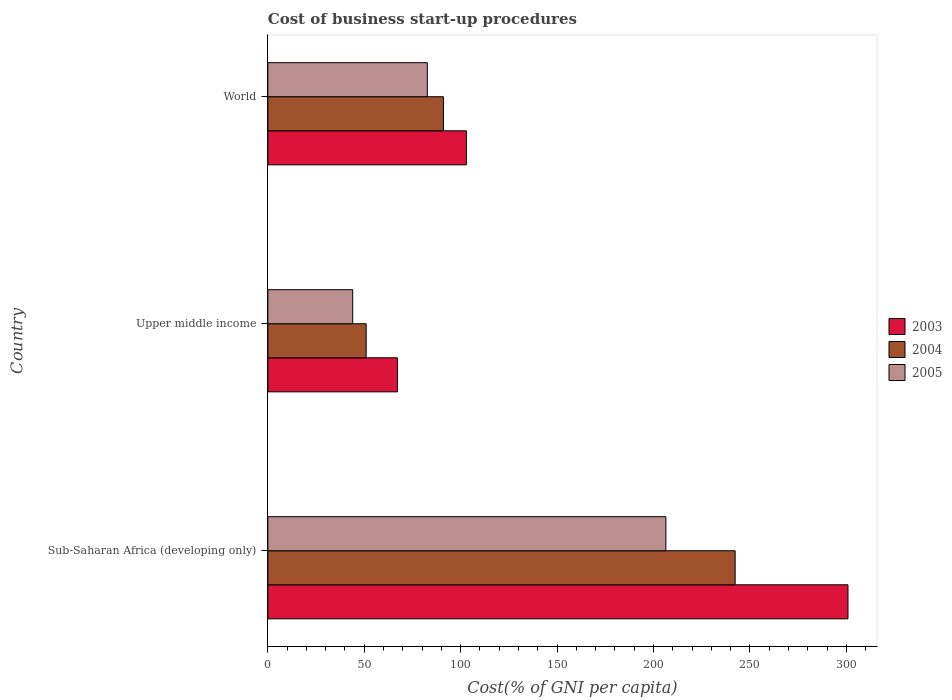How many different coloured bars are there?
Offer a very short reply. 3. How many groups of bars are there?
Give a very brief answer. 3. Are the number of bars per tick equal to the number of legend labels?
Offer a very short reply. Yes. What is the label of the 3rd group of bars from the top?
Your answer should be compact. Sub-Saharan Africa (developing only). In how many cases, is the number of bars for a given country not equal to the number of legend labels?
Your answer should be compact. 0. What is the cost of business start-up procedures in 2005 in Sub-Saharan Africa (developing only)?
Keep it short and to the point. 206.42. Across all countries, what is the maximum cost of business start-up procedures in 2005?
Make the answer very short. 206.42. Across all countries, what is the minimum cost of business start-up procedures in 2005?
Your response must be concise. 44.01. In which country was the cost of business start-up procedures in 2004 maximum?
Give a very brief answer. Sub-Saharan Africa (developing only). In which country was the cost of business start-up procedures in 2004 minimum?
Make the answer very short. Upper middle income. What is the total cost of business start-up procedures in 2003 in the graph?
Your answer should be compact. 471.05. What is the difference between the cost of business start-up procedures in 2005 in Sub-Saharan Africa (developing only) and that in Upper middle income?
Keep it short and to the point. 162.41. What is the difference between the cost of business start-up procedures in 2005 in Upper middle income and the cost of business start-up procedures in 2003 in Sub-Saharan Africa (developing only)?
Keep it short and to the point. -256.86. What is the average cost of business start-up procedures in 2003 per country?
Offer a terse response. 157.02. What is the difference between the cost of business start-up procedures in 2004 and cost of business start-up procedures in 2005 in World?
Your response must be concise. 8.36. In how many countries, is the cost of business start-up procedures in 2003 greater than 240 %?
Make the answer very short. 1. What is the ratio of the cost of business start-up procedures in 2005 in Sub-Saharan Africa (developing only) to that in World?
Give a very brief answer. 2.5. Is the cost of business start-up procedures in 2003 in Upper middle income less than that in World?
Provide a succinct answer. Yes. Is the difference between the cost of business start-up procedures in 2004 in Upper middle income and World greater than the difference between the cost of business start-up procedures in 2005 in Upper middle income and World?
Give a very brief answer. No. What is the difference between the highest and the second highest cost of business start-up procedures in 2004?
Your answer should be compact. 151.29. What is the difference between the highest and the lowest cost of business start-up procedures in 2005?
Your answer should be very brief. 162.41. In how many countries, is the cost of business start-up procedures in 2004 greater than the average cost of business start-up procedures in 2004 taken over all countries?
Your answer should be very brief. 1. What does the 1st bar from the bottom in Sub-Saharan Africa (developing only) represents?
Keep it short and to the point. 2003. Are all the bars in the graph horizontal?
Ensure brevity in your answer.  Yes. How many countries are there in the graph?
Your answer should be compact. 3. What is the difference between two consecutive major ticks on the X-axis?
Make the answer very short. 50. Where does the legend appear in the graph?
Your response must be concise. Center right. How many legend labels are there?
Your answer should be very brief. 3. How are the legend labels stacked?
Offer a terse response. Vertical. What is the title of the graph?
Keep it short and to the point. Cost of business start-up procedures. Does "1993" appear as one of the legend labels in the graph?
Offer a very short reply. No. What is the label or title of the X-axis?
Provide a succinct answer. Cost(% of GNI per capita). What is the Cost(% of GNI per capita) of 2003 in Sub-Saharan Africa (developing only)?
Your answer should be compact. 300.87. What is the Cost(% of GNI per capita) of 2004 in Sub-Saharan Africa (developing only)?
Offer a terse response. 242.35. What is the Cost(% of GNI per capita) of 2005 in Sub-Saharan Africa (developing only)?
Ensure brevity in your answer.  206.42. What is the Cost(% of GNI per capita) of 2003 in Upper middle income?
Offer a very short reply. 67.19. What is the Cost(% of GNI per capita) in 2004 in Upper middle income?
Ensure brevity in your answer.  51. What is the Cost(% of GNI per capita) of 2005 in Upper middle income?
Provide a succinct answer. 44.01. What is the Cost(% of GNI per capita) in 2003 in World?
Offer a very short reply. 103. What is the Cost(% of GNI per capita) in 2004 in World?
Provide a short and direct response. 91.06. What is the Cost(% of GNI per capita) in 2005 in World?
Offer a very short reply. 82.7. Across all countries, what is the maximum Cost(% of GNI per capita) in 2003?
Your answer should be very brief. 300.87. Across all countries, what is the maximum Cost(% of GNI per capita) in 2004?
Give a very brief answer. 242.35. Across all countries, what is the maximum Cost(% of GNI per capita) in 2005?
Offer a very short reply. 206.42. Across all countries, what is the minimum Cost(% of GNI per capita) of 2003?
Make the answer very short. 67.19. Across all countries, what is the minimum Cost(% of GNI per capita) of 2004?
Ensure brevity in your answer.  51. Across all countries, what is the minimum Cost(% of GNI per capita) in 2005?
Provide a succinct answer. 44.01. What is the total Cost(% of GNI per capita) in 2003 in the graph?
Make the answer very short. 471.05. What is the total Cost(% of GNI per capita) in 2004 in the graph?
Your response must be concise. 384.41. What is the total Cost(% of GNI per capita) in 2005 in the graph?
Ensure brevity in your answer.  333.13. What is the difference between the Cost(% of GNI per capita) of 2003 in Sub-Saharan Africa (developing only) and that in Upper middle income?
Your answer should be very brief. 233.68. What is the difference between the Cost(% of GNI per capita) in 2004 in Sub-Saharan Africa (developing only) and that in Upper middle income?
Make the answer very short. 191.35. What is the difference between the Cost(% of GNI per capita) in 2005 in Sub-Saharan Africa (developing only) and that in Upper middle income?
Keep it short and to the point. 162.41. What is the difference between the Cost(% of GNI per capita) of 2003 in Sub-Saharan Africa (developing only) and that in World?
Keep it short and to the point. 197.87. What is the difference between the Cost(% of GNI per capita) of 2004 in Sub-Saharan Africa (developing only) and that in World?
Offer a very short reply. 151.29. What is the difference between the Cost(% of GNI per capita) in 2005 in Sub-Saharan Africa (developing only) and that in World?
Your answer should be compact. 123.72. What is the difference between the Cost(% of GNI per capita) in 2003 in Upper middle income and that in World?
Make the answer very short. -35.81. What is the difference between the Cost(% of GNI per capita) in 2004 in Upper middle income and that in World?
Your response must be concise. -40.06. What is the difference between the Cost(% of GNI per capita) in 2005 in Upper middle income and that in World?
Your response must be concise. -38.69. What is the difference between the Cost(% of GNI per capita) of 2003 in Sub-Saharan Africa (developing only) and the Cost(% of GNI per capita) of 2004 in Upper middle income?
Offer a terse response. 249.87. What is the difference between the Cost(% of GNI per capita) of 2003 in Sub-Saharan Africa (developing only) and the Cost(% of GNI per capita) of 2005 in Upper middle income?
Keep it short and to the point. 256.86. What is the difference between the Cost(% of GNI per capita) in 2004 in Sub-Saharan Africa (developing only) and the Cost(% of GNI per capita) in 2005 in Upper middle income?
Give a very brief answer. 198.34. What is the difference between the Cost(% of GNI per capita) of 2003 in Sub-Saharan Africa (developing only) and the Cost(% of GNI per capita) of 2004 in World?
Ensure brevity in your answer.  209.81. What is the difference between the Cost(% of GNI per capita) of 2003 in Sub-Saharan Africa (developing only) and the Cost(% of GNI per capita) of 2005 in World?
Your answer should be very brief. 218.17. What is the difference between the Cost(% of GNI per capita) in 2004 in Sub-Saharan Africa (developing only) and the Cost(% of GNI per capita) in 2005 in World?
Offer a very short reply. 159.65. What is the difference between the Cost(% of GNI per capita) in 2003 in Upper middle income and the Cost(% of GNI per capita) in 2004 in World?
Your answer should be very brief. -23.87. What is the difference between the Cost(% of GNI per capita) in 2003 in Upper middle income and the Cost(% of GNI per capita) in 2005 in World?
Offer a very short reply. -15.51. What is the difference between the Cost(% of GNI per capita) of 2004 in Upper middle income and the Cost(% of GNI per capita) of 2005 in World?
Your answer should be compact. -31.7. What is the average Cost(% of GNI per capita) in 2003 per country?
Your response must be concise. 157.02. What is the average Cost(% of GNI per capita) in 2004 per country?
Ensure brevity in your answer.  128.14. What is the average Cost(% of GNI per capita) in 2005 per country?
Your response must be concise. 111.04. What is the difference between the Cost(% of GNI per capita) of 2003 and Cost(% of GNI per capita) of 2004 in Sub-Saharan Africa (developing only)?
Give a very brief answer. 58.52. What is the difference between the Cost(% of GNI per capita) of 2003 and Cost(% of GNI per capita) of 2005 in Sub-Saharan Africa (developing only)?
Ensure brevity in your answer.  94.45. What is the difference between the Cost(% of GNI per capita) in 2004 and Cost(% of GNI per capita) in 2005 in Sub-Saharan Africa (developing only)?
Your response must be concise. 35.93. What is the difference between the Cost(% of GNI per capita) of 2003 and Cost(% of GNI per capita) of 2004 in Upper middle income?
Offer a very short reply. 16.19. What is the difference between the Cost(% of GNI per capita) of 2003 and Cost(% of GNI per capita) of 2005 in Upper middle income?
Your response must be concise. 23.18. What is the difference between the Cost(% of GNI per capita) of 2004 and Cost(% of GNI per capita) of 2005 in Upper middle income?
Offer a terse response. 6.99. What is the difference between the Cost(% of GNI per capita) in 2003 and Cost(% of GNI per capita) in 2004 in World?
Ensure brevity in your answer.  11.94. What is the difference between the Cost(% of GNI per capita) in 2003 and Cost(% of GNI per capita) in 2005 in World?
Your answer should be very brief. 20.3. What is the difference between the Cost(% of GNI per capita) in 2004 and Cost(% of GNI per capita) in 2005 in World?
Keep it short and to the point. 8.36. What is the ratio of the Cost(% of GNI per capita) in 2003 in Sub-Saharan Africa (developing only) to that in Upper middle income?
Provide a short and direct response. 4.48. What is the ratio of the Cost(% of GNI per capita) in 2004 in Sub-Saharan Africa (developing only) to that in Upper middle income?
Offer a terse response. 4.75. What is the ratio of the Cost(% of GNI per capita) of 2005 in Sub-Saharan Africa (developing only) to that in Upper middle income?
Your response must be concise. 4.69. What is the ratio of the Cost(% of GNI per capita) in 2003 in Sub-Saharan Africa (developing only) to that in World?
Provide a short and direct response. 2.92. What is the ratio of the Cost(% of GNI per capita) of 2004 in Sub-Saharan Africa (developing only) to that in World?
Your answer should be compact. 2.66. What is the ratio of the Cost(% of GNI per capita) of 2005 in Sub-Saharan Africa (developing only) to that in World?
Give a very brief answer. 2.5. What is the ratio of the Cost(% of GNI per capita) of 2003 in Upper middle income to that in World?
Keep it short and to the point. 0.65. What is the ratio of the Cost(% of GNI per capita) of 2004 in Upper middle income to that in World?
Offer a very short reply. 0.56. What is the ratio of the Cost(% of GNI per capita) of 2005 in Upper middle income to that in World?
Your response must be concise. 0.53. What is the difference between the highest and the second highest Cost(% of GNI per capita) in 2003?
Your answer should be compact. 197.87. What is the difference between the highest and the second highest Cost(% of GNI per capita) of 2004?
Your answer should be very brief. 151.29. What is the difference between the highest and the second highest Cost(% of GNI per capita) of 2005?
Offer a terse response. 123.72. What is the difference between the highest and the lowest Cost(% of GNI per capita) of 2003?
Offer a very short reply. 233.68. What is the difference between the highest and the lowest Cost(% of GNI per capita) of 2004?
Ensure brevity in your answer.  191.35. What is the difference between the highest and the lowest Cost(% of GNI per capita) in 2005?
Your response must be concise. 162.41. 